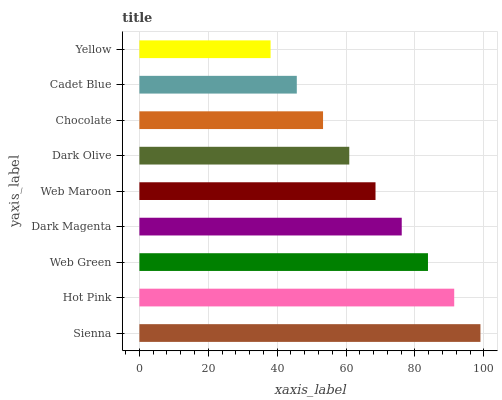Is Yellow the minimum?
Answer yes or no. Yes. Is Sienna the maximum?
Answer yes or no. Yes. Is Hot Pink the minimum?
Answer yes or no. No. Is Hot Pink the maximum?
Answer yes or no. No. Is Sienna greater than Hot Pink?
Answer yes or no. Yes. Is Hot Pink less than Sienna?
Answer yes or no. Yes. Is Hot Pink greater than Sienna?
Answer yes or no. No. Is Sienna less than Hot Pink?
Answer yes or no. No. Is Web Maroon the high median?
Answer yes or no. Yes. Is Web Maroon the low median?
Answer yes or no. Yes. Is Chocolate the high median?
Answer yes or no. No. Is Chocolate the low median?
Answer yes or no. No. 